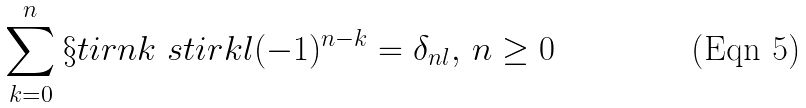<formula> <loc_0><loc_0><loc_500><loc_500>\sum _ { k = 0 } ^ { n } \S t i r { n } { k } \ s t i r { k } { l } ( - 1 ) ^ { n - k } = \delta _ { n l } , \, n \geq 0</formula> 